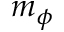<formula> <loc_0><loc_0><loc_500><loc_500>m _ { \phi }</formula> 